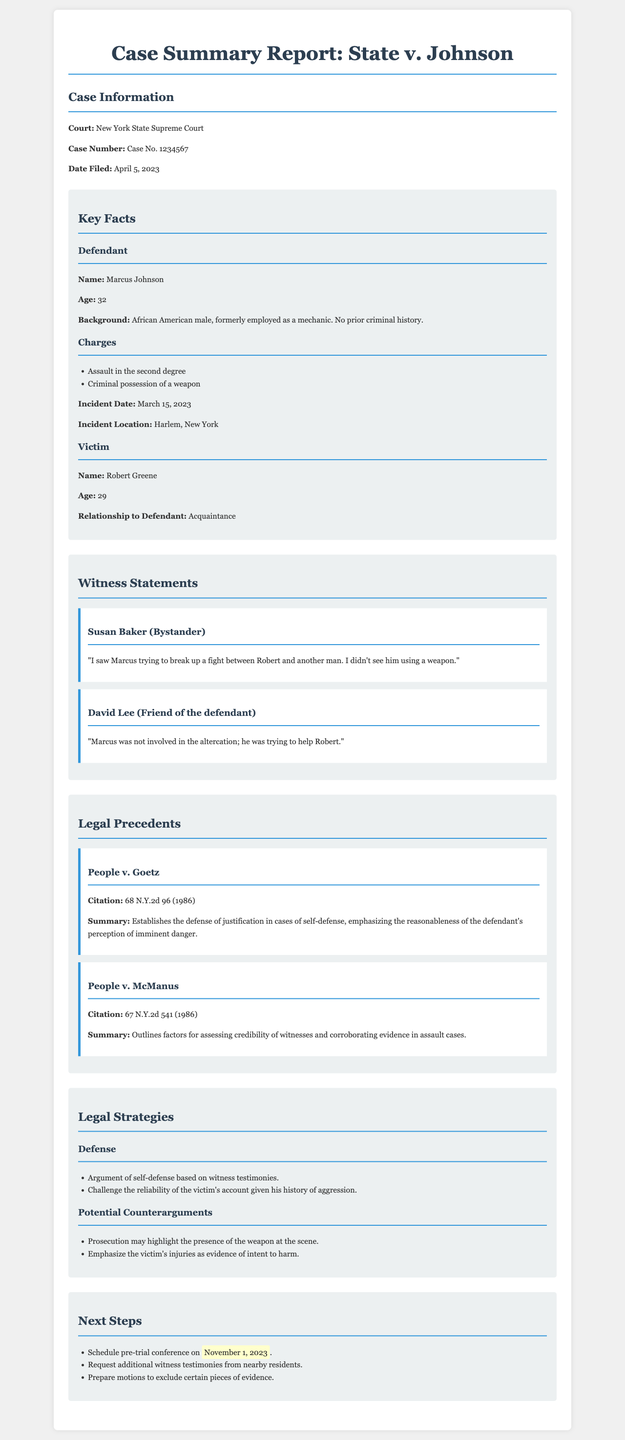What is the defendant's name? The defendant's name is explicitly stated in the key facts section of the document.
Answer: Marcus Johnson What is the date the case was filed? The document mentions the filing date clearly in the case information section.
Answer: April 5, 2023 What charges are brought against the defendant? The document lists the charges in the key facts section.
Answer: Assault in the second degree, Criminal possession of a weapon Who provided the statement that Marcus was trying to break up a fight? The document includes witness statements, identifying who said what.
Answer: Susan Baker What is the citation for the legal precedent "People v. Goetz"? The citation for the legal precedent is provided in the legal precedents section.
Answer: 68 N.Y.2d 96 (1986) What is the age of the victim? The document explicitly states the victim's age in the key facts section.
Answer: 29 What is the main defense strategy mentioned? The defense strategies are outlined in the legal strategies section of the document.
Answer: Argument of self-defense based on witness testimonies When is the next scheduled pre-trial conference? The date for the next steps in the case is listed in the next steps section.
Answer: November 1, 2023 What relationship does the victim have to the defendant? The document specifies the relationship in the key facts section.
Answer: Acquaintance 